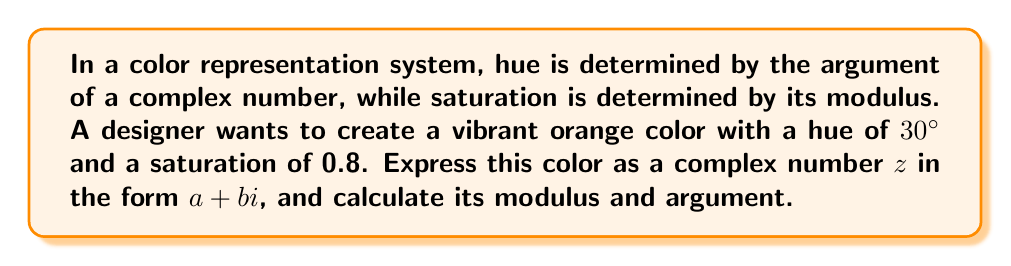Solve this math problem. To solve this problem, we'll follow these steps:

1) First, let's recall that a complex number can be represented in polar form as:
   
   $z = r(\cos\theta + i\sin\theta)$

   where $r$ is the modulus and $\theta$ is the argument.

2) We're given that the saturation (modulus) is 0.8 and the hue (argument) is 30°. So:
   
   $r = 0.8$
   $\theta = 30° = \frac{\pi}{6}$ radians

3) Substituting these into the polar form:

   $z = 0.8(\cos\frac{\pi}{6} + i\sin\frac{\pi}{6})$

4) Now, let's calculate the real and imaginary parts:

   $\cos\frac{\pi}{6} = \frac{\sqrt{3}}{2} \approx 0.866$
   $\sin\frac{\pi}{6} = \frac{1}{2} = 0.5$

5) Multiplying by 0.8:

   $z = 0.8(\frac{\sqrt{3}}{2} + i\frac{1}{2})$
   $z = 0.8 \cdot \frac{\sqrt{3}}{2} + 0.8 \cdot \frac{1}{2}i$
   $z = 0.4\sqrt{3} + 0.4i$

6) The modulus is already given as 0.8.

7) To calculate the argument, we can use the arctangent function:

   $\theta = \arctan(\frac{\text{Im}(z)}{\text{Re}(z)}) = \arctan(\frac{0.4}{0.4\sqrt{3}}) = \arctan(\frac{1}{\sqrt{3}}) = 30°$

   This confirms our original hue value.
Answer: $z = 0.4\sqrt{3} + 0.4i$, modulus $= 0.8$, argument $= 30°$ 